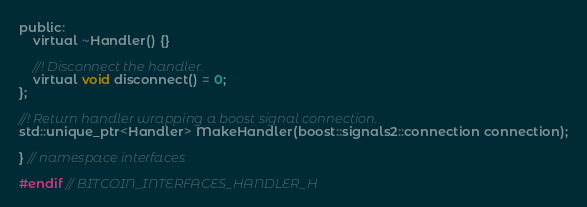Convert code to text. <code><loc_0><loc_0><loc_500><loc_500><_C_>public:
    virtual ~Handler() {}

    //! Disconnect the handler.
    virtual void disconnect() = 0;
};

//! Return handler wrapping a boost signal connection.
std::unique_ptr<Handler> MakeHandler(boost::signals2::connection connection);

} // namespace interfaces

#endif // BITCOIN_INTERFACES_HANDLER_H
</code> 